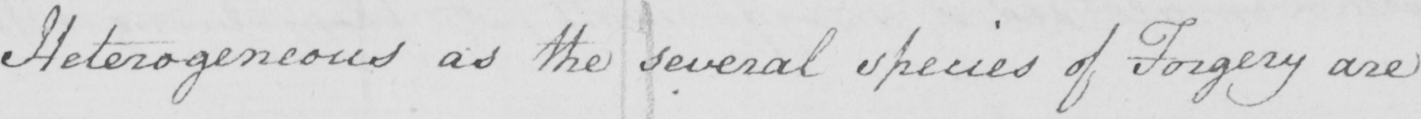Please transcribe the handwritten text in this image. Heterogeneous as the several species of Forgery are 